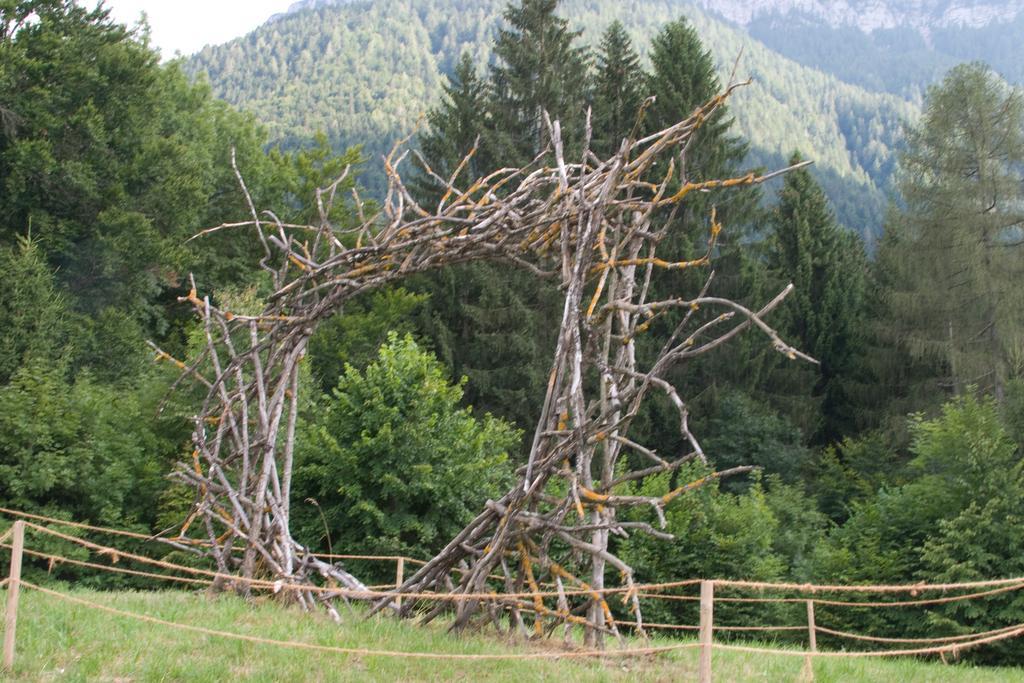In one or two sentences, can you explain what this image depicts? In the center of the image we can see the grass, one arch with branches and fence with poles and ropes. In the background, we can see the sky and trees. 